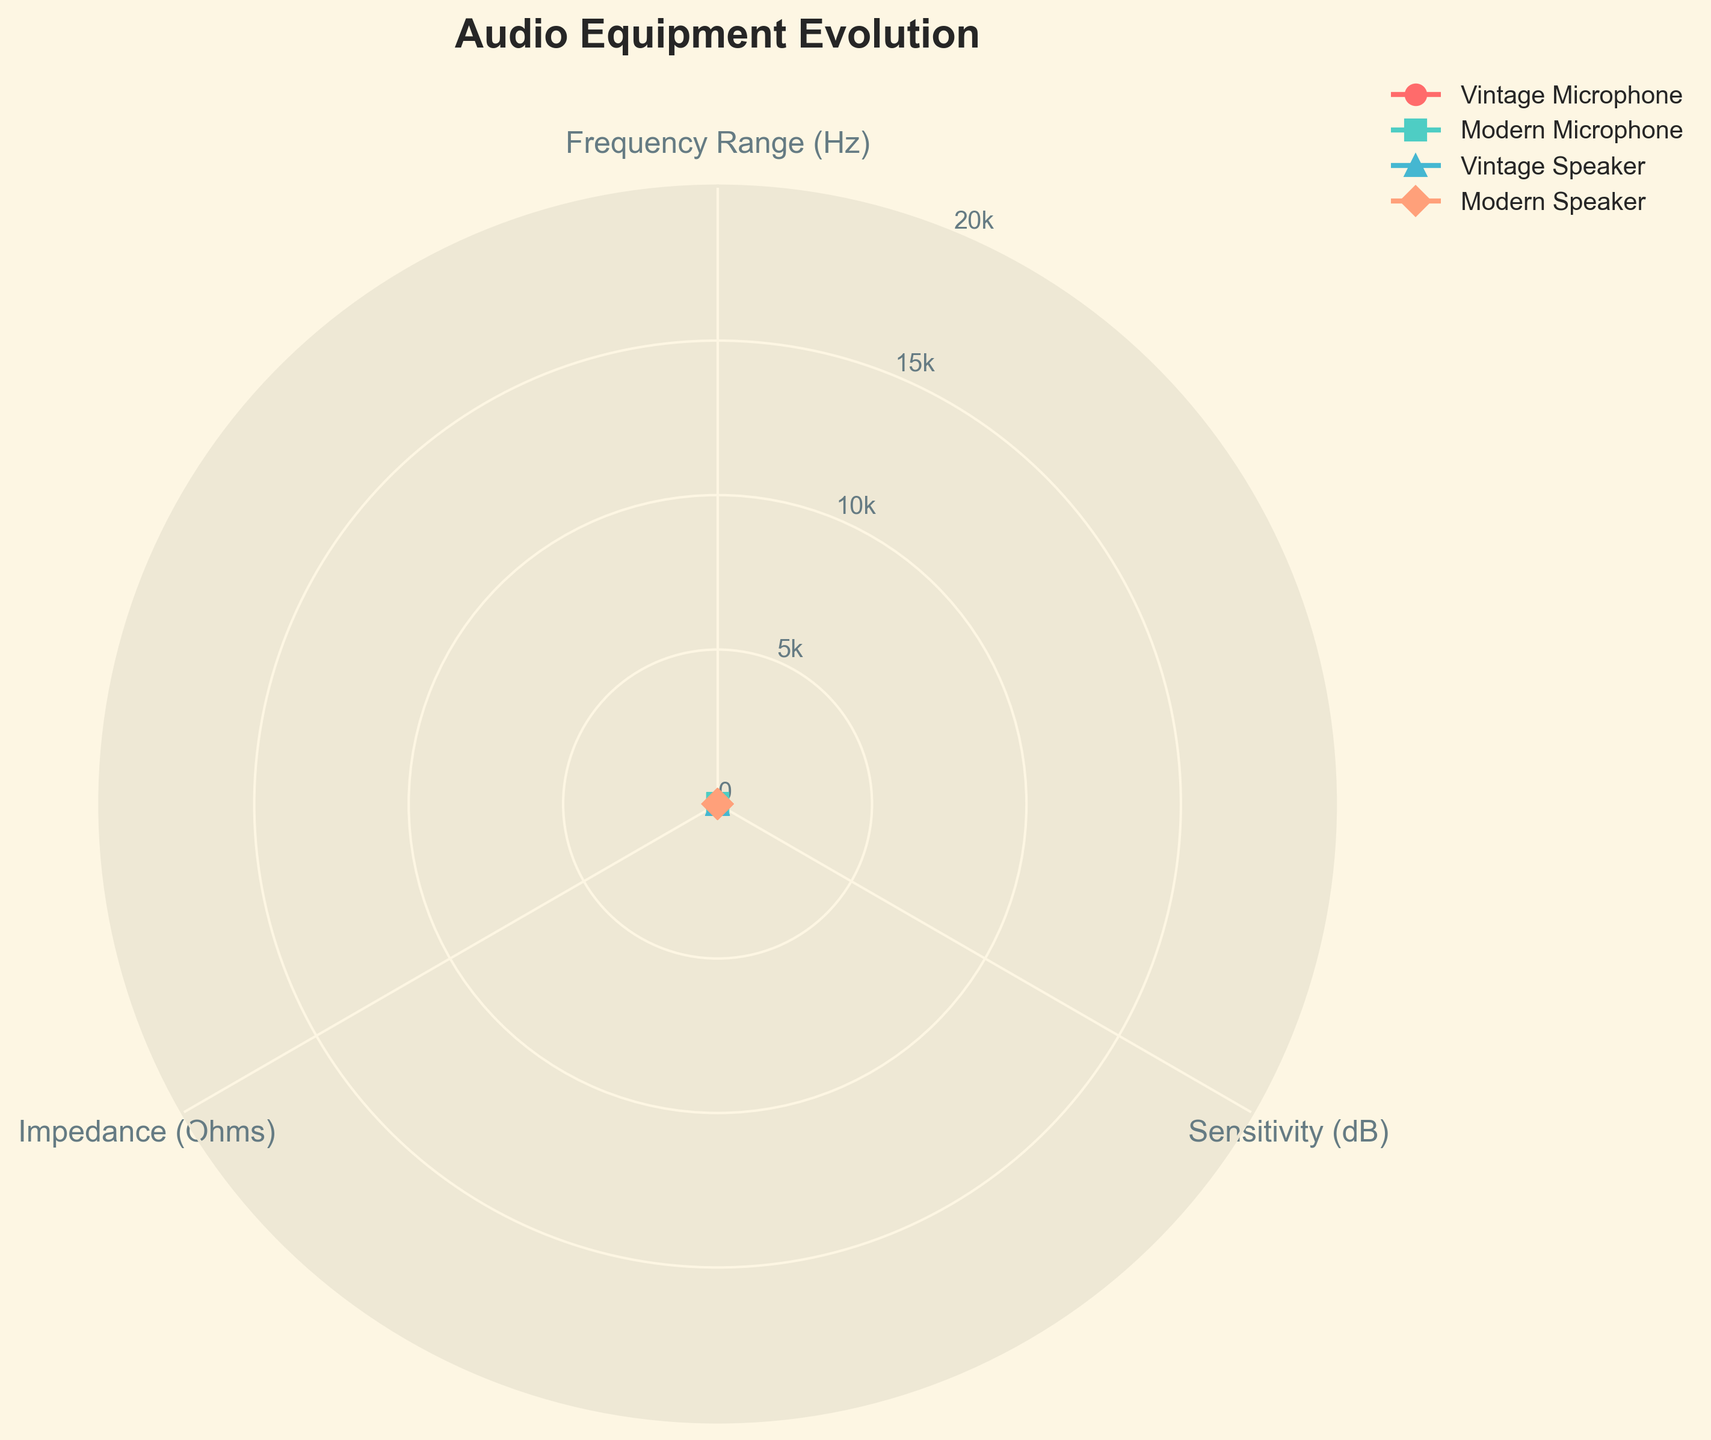Which category has the widest frequency range? By observing the radar chart, we see that the Modern Microphone has a frequency range extending from 20 Hz to 20000 Hz, which is the widest among the categories.
Answer: Modern Microphone Which category shows the highest sensitivity in dB? The radar chart indicates that the Modern Speaker has the highest sensitivity, reaching up to 110 dB.
Answer: Modern Speaker What is the impedance value for the Vintage Microphone? By directly looking at the radar chart, the impedance of the Vintage Microphone is 150 Ohms.
Answer: 150 Ohms Between Vintage and Modern Speakers, which one has a wider frequency range? Comparing the frequency ranges in the radar chart, the Modern Speaker spans from 30 Hz to 22000 Hz, while the Vintage Speaker ranges from 50 Hz to 14000 Hz; thus, the Modern Speaker has the wider frequency range.
Answer: Modern Speaker How do the sensitivity levels of the Vintage Microphone and Modern Microphone compare? In the radar chart, the Modern Microphone has a sensitivity of 100 dB, whereas the Vintage Microphone shows a sensitivity of 85 dB. Hence, the Modern Microphone has a higher sensitivity.
Answer: Modern Microphone What's the difference in impedance between the Vintage Speaker and Modern Speaker? From the radar chart, the Vintage Speaker has an impedance of 8 Ohms, and the Modern Speaker has 6 Ohms. The difference is 8 - 6 = 2 Ohms.
Answer: 2 Ohms Which category has the lowest impedance? Observing the radar chart, the Modern Speaker has the lowest impedance value of 6 Ohms.
Answer: Modern Speaker What is the mean sensitivity value of all categories? The sensitivity values are: Vintage Microphone (85 dB), Modern Microphone (100 dB), Vintage Speaker (90 dB), Modern Speaker (110 dB). Their mean is (85 + 100 + 90 + 110) / 4 = 96.25 dB.
Answer: 96.25 dB What is the combined frequency range of both vintage categories? The frequency ranges are: Vintage Microphone (40 Hz to 15000 Hz) and Vintage Speaker (50 Hz to 14000 Hz). Combining these ranges covers from 40 Hz to 15000 Hz.
Answer: 40 Hz to 15000 Hz Comparing impedance, which has a greater value: the Vintage Microphone or Modern Microphone? In the radar chart, the impedance values are 150 Ohms for the Vintage Microphone and 200 Ohms for the Modern Microphone. Therefore, the Modern Microphone has a greater impedance.
Answer: Modern Microphone 